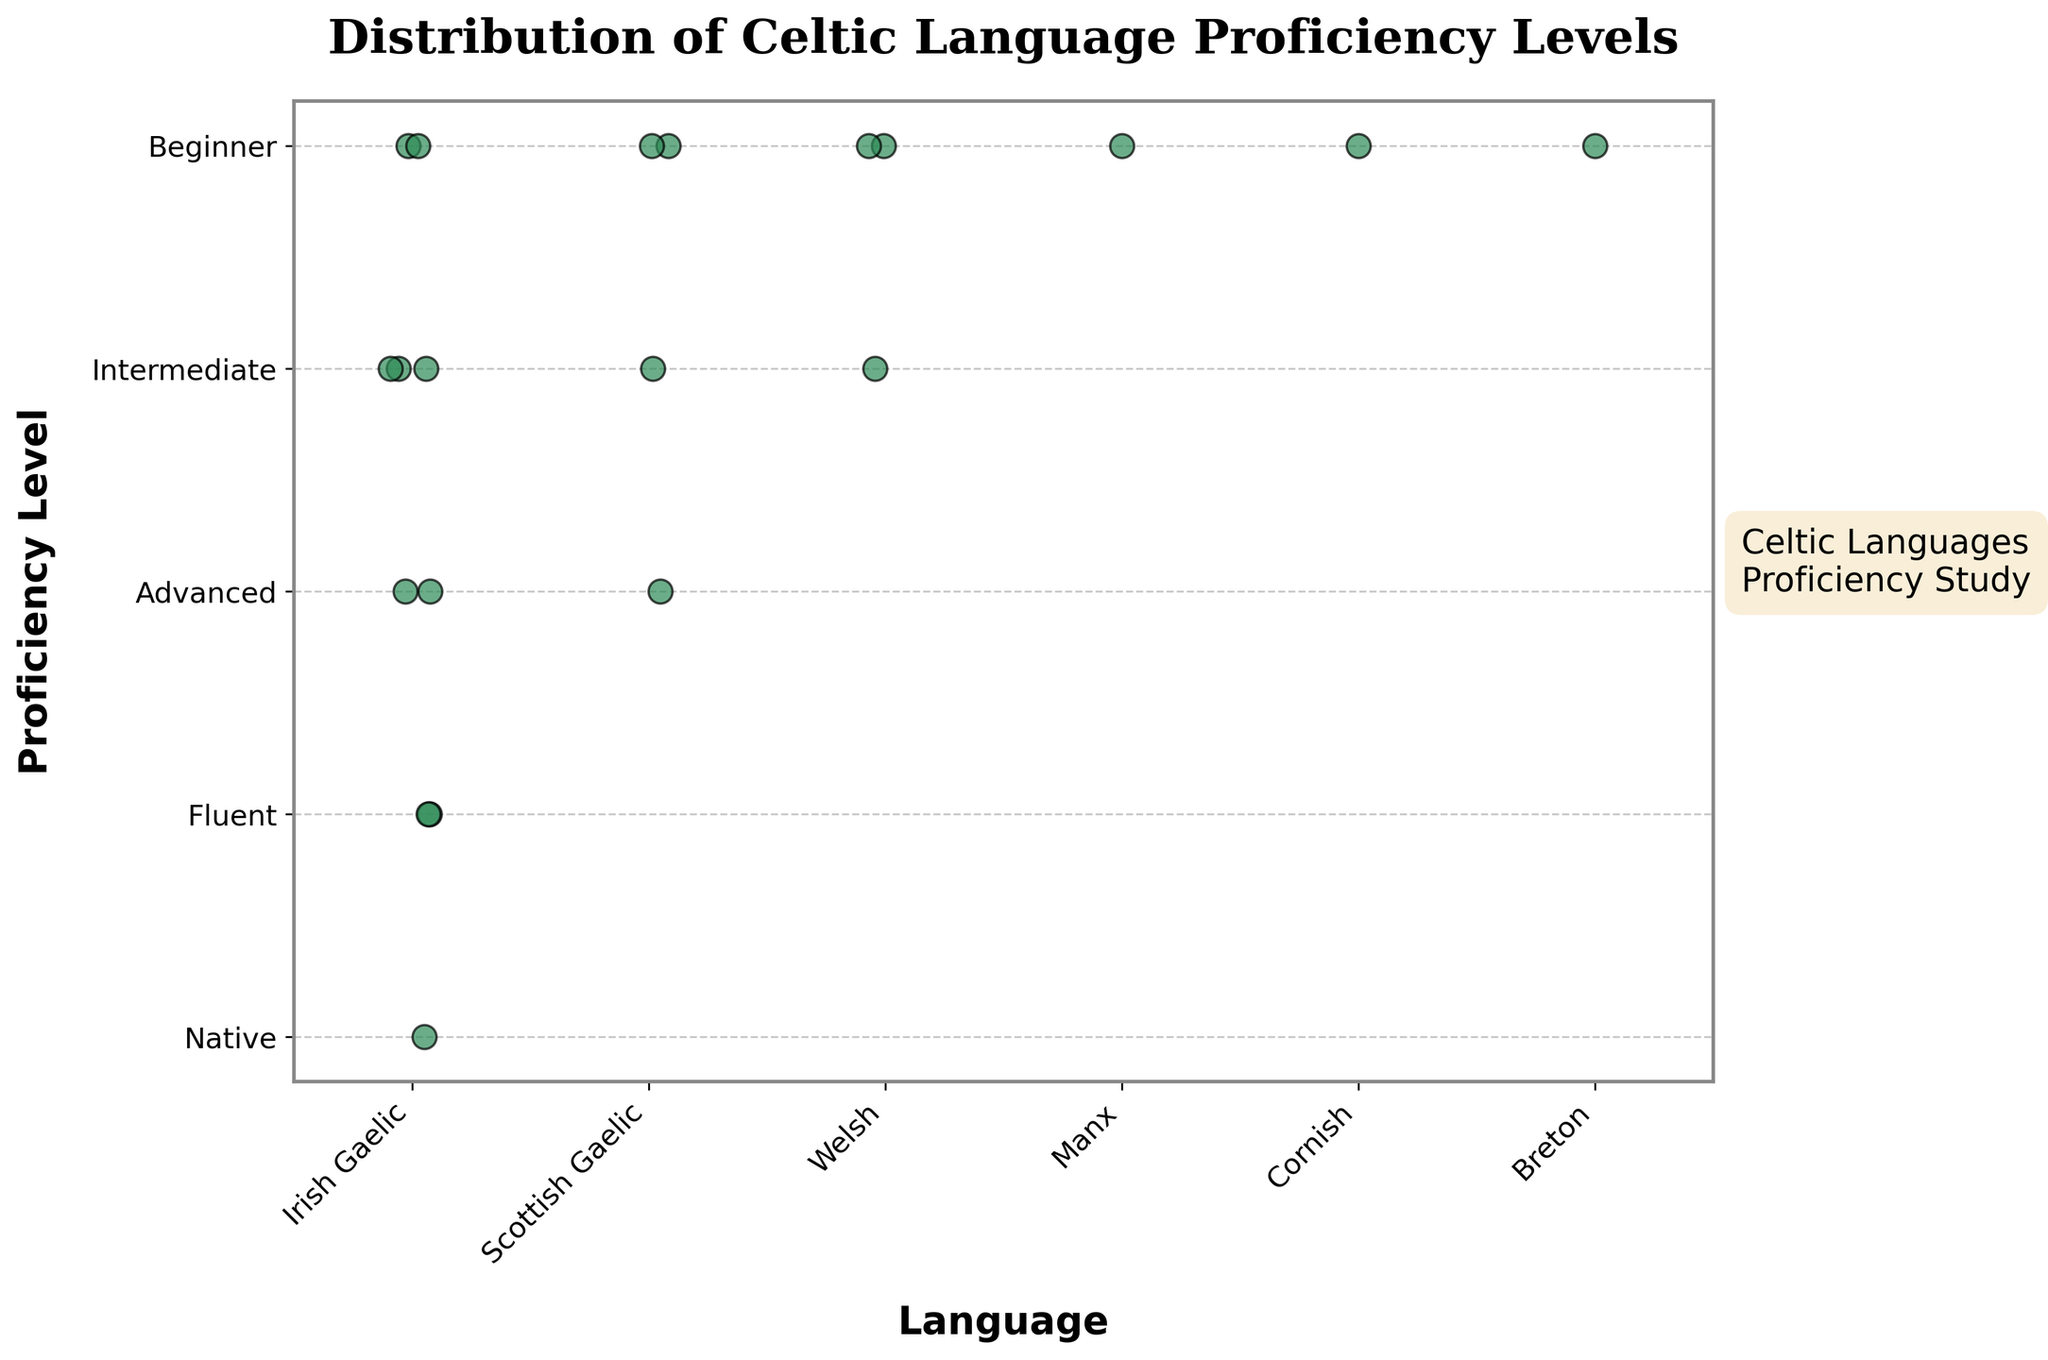What does the title of the figure indicate? The title "Distribution of Celtic Language Proficiency Levels" indicates that the figure shows how proficiency levels in various Celtic languages are distributed among a group of people.
Answer: Distribution of Celtic Language Proficiency Levels How many different languages are displayed in the figure? The figure shows different languages along the x-axis, and the labels indicate Irish Gaelic, Scottish Gaelic, Welsh, Manx, Cornish, and Breton. Counting these labels gives us 6 different languages.
Answer: 6 Which language has the most data points at the "Beginner" proficiency level? By observing the number of points at the "Beginner" proficiency level for each language, we can see that Irish Gaelic has the most points clustered around this level.
Answer: Irish Gaelic Are there any languages that do not have any data points at the "Advanced" proficiency level? The figure shows data points for proficiency levels from "Beginner" to "Native". Observing the "Advanced" level, Manx, Cornish, and Breton do not have any data points at this level.
Answer: Manx, Cornish, Breton How many total data points are represented in the figure? We can count the individual points scattered across various proficiency levels for all languages. There are a total of 19 points.
Answer: 19 Which proficiency level has the most data points overall? We observe the density of points across all languages for each proficiency level. The "Beginner" level has the highest density of points.
Answer: Beginner How does the distribution of proficiency levels in Irish Gaelic compare to Scottish Gaelic? In Irish Gaelic, data points are spread across all proficiency levels from "Beginner" to "Native", while Scottish Gaelic has points primarily in the "Beginner" and "Intermediate" levels.
Answer: Irish Gaelic has a wider distribution across levels Which two languages have data points at the "Native" proficiency level? We check the distribution of data points along the "Native" proficiency level and find that only Irish Gaelic has points at this level. No other language does.
Answer: Only Irish Gaelic What is the highest proficiency level reached in Welsh? Observing the data points for Welsh across all proficiency levels, the highest level displayed is "Intermediate".
Answer: Intermediate How many languages have data points at the "Fluent" proficiency level? We check the data points at the "Fluent" level and find that both Irish Gaelic and Scottish Gaelic have points at this level.
Answer: 2 